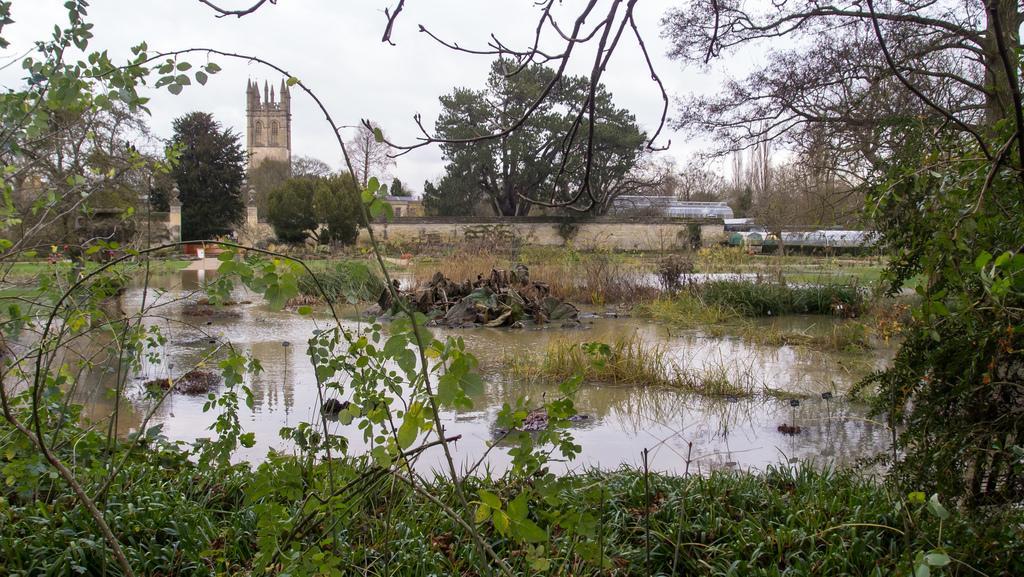Describe this image in one or two sentences. In this image there is the sky, there is a building, there are trees, there are plants truncated towards the bottom of the image, there is the grass, there is water on the ground, there are trees truncated towards the right of the image, there are plants truncated towards the left of the image, there is the wall. 